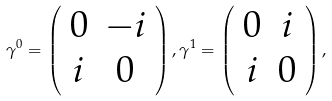Convert formula to latex. <formula><loc_0><loc_0><loc_500><loc_500>\gamma ^ { 0 } = \left ( \begin{array} { c c } 0 & - i \\ i & 0 \end{array} \right ) , \gamma ^ { 1 } = \left ( \begin{array} { c c } 0 & i \\ i & 0 \end{array} \right ) ,</formula> 